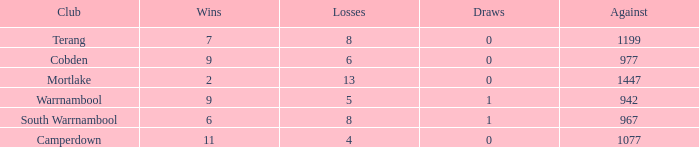What's the number of losses when the wins were more than 11 and had 0 draws? 0.0. 